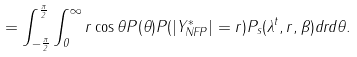<formula> <loc_0><loc_0><loc_500><loc_500>= \int _ { - \frac { \pi } { 2 } } ^ { \frac { \pi } { 2 } } \int _ { 0 } ^ { \infty } r \cos \theta P ( \theta ) P ( | Y ^ { * } _ { N F P } | = r ) P _ { s } ( \lambda ^ { t } , r , \beta ) d r d \theta .</formula> 